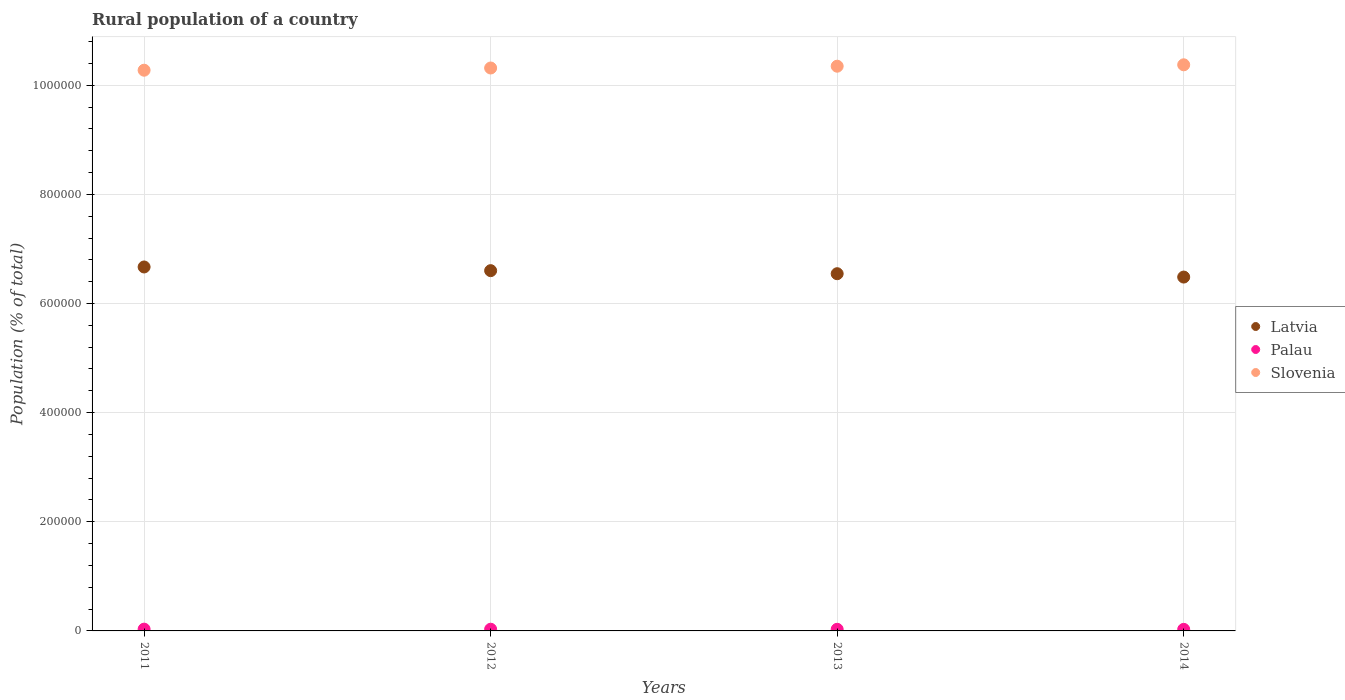How many different coloured dotlines are there?
Keep it short and to the point. 3. What is the rural population in Slovenia in 2013?
Offer a very short reply. 1.03e+06. Across all years, what is the maximum rural population in Latvia?
Provide a succinct answer. 6.67e+05. Across all years, what is the minimum rural population in Latvia?
Your response must be concise. 6.48e+05. In which year was the rural population in Slovenia maximum?
Your answer should be compact. 2014. In which year was the rural population in Palau minimum?
Your answer should be compact. 2014. What is the total rural population in Slovenia in the graph?
Keep it short and to the point. 4.13e+06. What is the difference between the rural population in Slovenia in 2011 and that in 2014?
Give a very brief answer. -9910. What is the difference between the rural population in Latvia in 2013 and the rural population in Palau in 2014?
Make the answer very short. 6.52e+05. What is the average rural population in Palau per year?
Ensure brevity in your answer.  3047. In the year 2011, what is the difference between the rural population in Slovenia and rural population in Palau?
Ensure brevity in your answer.  1.02e+06. In how many years, is the rural population in Slovenia greater than 960000 %?
Provide a succinct answer. 4. What is the ratio of the rural population in Palau in 2013 to that in 2014?
Provide a short and direct response. 1.04. Is the difference between the rural population in Slovenia in 2013 and 2014 greater than the difference between the rural population in Palau in 2013 and 2014?
Your answer should be very brief. No. What is the difference between the highest and the second highest rural population in Slovenia?
Your answer should be very brief. 2561. What is the difference between the highest and the lowest rural population in Palau?
Your response must be concise. 391. Does the rural population in Latvia monotonically increase over the years?
Offer a terse response. No. Is the rural population in Latvia strictly greater than the rural population in Slovenia over the years?
Provide a short and direct response. No. How many dotlines are there?
Ensure brevity in your answer.  3. What is the difference between two consecutive major ticks on the Y-axis?
Provide a succinct answer. 2.00e+05. Are the values on the major ticks of Y-axis written in scientific E-notation?
Your answer should be very brief. No. Does the graph contain grids?
Provide a succinct answer. Yes. How many legend labels are there?
Provide a succinct answer. 3. What is the title of the graph?
Provide a short and direct response. Rural population of a country. What is the label or title of the X-axis?
Give a very brief answer. Years. What is the label or title of the Y-axis?
Provide a short and direct response. Population (% of total). What is the Population (% of total) in Latvia in 2011?
Give a very brief answer. 6.67e+05. What is the Population (% of total) in Palau in 2011?
Offer a very short reply. 3249. What is the Population (% of total) in Slovenia in 2011?
Make the answer very short. 1.03e+06. What is the Population (% of total) in Latvia in 2012?
Keep it short and to the point. 6.60e+05. What is the Population (% of total) in Palau in 2012?
Make the answer very short. 3105. What is the Population (% of total) of Slovenia in 2012?
Provide a short and direct response. 1.03e+06. What is the Population (% of total) of Latvia in 2013?
Provide a short and direct response. 6.55e+05. What is the Population (% of total) of Palau in 2013?
Give a very brief answer. 2976. What is the Population (% of total) of Slovenia in 2013?
Give a very brief answer. 1.03e+06. What is the Population (% of total) of Latvia in 2014?
Your answer should be very brief. 6.48e+05. What is the Population (% of total) in Palau in 2014?
Provide a succinct answer. 2858. What is the Population (% of total) in Slovenia in 2014?
Make the answer very short. 1.04e+06. Across all years, what is the maximum Population (% of total) in Latvia?
Offer a terse response. 6.67e+05. Across all years, what is the maximum Population (% of total) in Palau?
Offer a terse response. 3249. Across all years, what is the maximum Population (% of total) of Slovenia?
Ensure brevity in your answer.  1.04e+06. Across all years, what is the minimum Population (% of total) of Latvia?
Provide a succinct answer. 6.48e+05. Across all years, what is the minimum Population (% of total) in Palau?
Offer a very short reply. 2858. Across all years, what is the minimum Population (% of total) in Slovenia?
Provide a succinct answer. 1.03e+06. What is the total Population (% of total) of Latvia in the graph?
Ensure brevity in your answer.  2.63e+06. What is the total Population (% of total) of Palau in the graph?
Your answer should be very brief. 1.22e+04. What is the total Population (% of total) of Slovenia in the graph?
Your answer should be very brief. 4.13e+06. What is the difference between the Population (% of total) in Latvia in 2011 and that in 2012?
Offer a terse response. 6757. What is the difference between the Population (% of total) of Palau in 2011 and that in 2012?
Your answer should be compact. 144. What is the difference between the Population (% of total) in Slovenia in 2011 and that in 2012?
Provide a succinct answer. -4053. What is the difference between the Population (% of total) of Latvia in 2011 and that in 2013?
Your response must be concise. 1.23e+04. What is the difference between the Population (% of total) in Palau in 2011 and that in 2013?
Give a very brief answer. 273. What is the difference between the Population (% of total) of Slovenia in 2011 and that in 2013?
Your answer should be compact. -7349. What is the difference between the Population (% of total) of Latvia in 2011 and that in 2014?
Provide a succinct answer. 1.85e+04. What is the difference between the Population (% of total) in Palau in 2011 and that in 2014?
Your answer should be compact. 391. What is the difference between the Population (% of total) of Slovenia in 2011 and that in 2014?
Your answer should be compact. -9910. What is the difference between the Population (% of total) of Latvia in 2012 and that in 2013?
Your response must be concise. 5584. What is the difference between the Population (% of total) in Palau in 2012 and that in 2013?
Your answer should be compact. 129. What is the difference between the Population (% of total) of Slovenia in 2012 and that in 2013?
Your answer should be compact. -3296. What is the difference between the Population (% of total) in Latvia in 2012 and that in 2014?
Provide a succinct answer. 1.17e+04. What is the difference between the Population (% of total) in Palau in 2012 and that in 2014?
Ensure brevity in your answer.  247. What is the difference between the Population (% of total) of Slovenia in 2012 and that in 2014?
Your answer should be compact. -5857. What is the difference between the Population (% of total) in Latvia in 2013 and that in 2014?
Provide a short and direct response. 6157. What is the difference between the Population (% of total) in Palau in 2013 and that in 2014?
Make the answer very short. 118. What is the difference between the Population (% of total) in Slovenia in 2013 and that in 2014?
Give a very brief answer. -2561. What is the difference between the Population (% of total) of Latvia in 2011 and the Population (% of total) of Palau in 2012?
Provide a short and direct response. 6.64e+05. What is the difference between the Population (% of total) in Latvia in 2011 and the Population (% of total) in Slovenia in 2012?
Give a very brief answer. -3.65e+05. What is the difference between the Population (% of total) in Palau in 2011 and the Population (% of total) in Slovenia in 2012?
Your response must be concise. -1.03e+06. What is the difference between the Population (% of total) in Latvia in 2011 and the Population (% of total) in Palau in 2013?
Ensure brevity in your answer.  6.64e+05. What is the difference between the Population (% of total) in Latvia in 2011 and the Population (% of total) in Slovenia in 2013?
Give a very brief answer. -3.68e+05. What is the difference between the Population (% of total) of Palau in 2011 and the Population (% of total) of Slovenia in 2013?
Offer a terse response. -1.03e+06. What is the difference between the Population (% of total) of Latvia in 2011 and the Population (% of total) of Palau in 2014?
Offer a very short reply. 6.64e+05. What is the difference between the Population (% of total) of Latvia in 2011 and the Population (% of total) of Slovenia in 2014?
Ensure brevity in your answer.  -3.70e+05. What is the difference between the Population (% of total) in Palau in 2011 and the Population (% of total) in Slovenia in 2014?
Your response must be concise. -1.03e+06. What is the difference between the Population (% of total) in Latvia in 2012 and the Population (% of total) in Palau in 2013?
Your answer should be compact. 6.57e+05. What is the difference between the Population (% of total) of Latvia in 2012 and the Population (% of total) of Slovenia in 2013?
Provide a succinct answer. -3.75e+05. What is the difference between the Population (% of total) in Palau in 2012 and the Population (% of total) in Slovenia in 2013?
Your response must be concise. -1.03e+06. What is the difference between the Population (% of total) in Latvia in 2012 and the Population (% of total) in Palau in 2014?
Give a very brief answer. 6.57e+05. What is the difference between the Population (% of total) in Latvia in 2012 and the Population (% of total) in Slovenia in 2014?
Your answer should be very brief. -3.77e+05. What is the difference between the Population (% of total) in Palau in 2012 and the Population (% of total) in Slovenia in 2014?
Provide a succinct answer. -1.03e+06. What is the difference between the Population (% of total) of Latvia in 2013 and the Population (% of total) of Palau in 2014?
Provide a succinct answer. 6.52e+05. What is the difference between the Population (% of total) in Latvia in 2013 and the Population (% of total) in Slovenia in 2014?
Your answer should be compact. -3.83e+05. What is the difference between the Population (% of total) in Palau in 2013 and the Population (% of total) in Slovenia in 2014?
Give a very brief answer. -1.03e+06. What is the average Population (% of total) in Latvia per year?
Make the answer very short. 6.58e+05. What is the average Population (% of total) of Palau per year?
Ensure brevity in your answer.  3047. What is the average Population (% of total) in Slovenia per year?
Give a very brief answer. 1.03e+06. In the year 2011, what is the difference between the Population (% of total) in Latvia and Population (% of total) in Palau?
Your answer should be compact. 6.64e+05. In the year 2011, what is the difference between the Population (% of total) in Latvia and Population (% of total) in Slovenia?
Keep it short and to the point. -3.61e+05. In the year 2011, what is the difference between the Population (% of total) of Palau and Population (% of total) of Slovenia?
Make the answer very short. -1.02e+06. In the year 2012, what is the difference between the Population (% of total) of Latvia and Population (% of total) of Palau?
Your response must be concise. 6.57e+05. In the year 2012, what is the difference between the Population (% of total) of Latvia and Population (% of total) of Slovenia?
Give a very brief answer. -3.71e+05. In the year 2012, what is the difference between the Population (% of total) of Palau and Population (% of total) of Slovenia?
Offer a very short reply. -1.03e+06. In the year 2013, what is the difference between the Population (% of total) in Latvia and Population (% of total) in Palau?
Provide a succinct answer. 6.52e+05. In the year 2013, what is the difference between the Population (% of total) of Latvia and Population (% of total) of Slovenia?
Keep it short and to the point. -3.80e+05. In the year 2013, what is the difference between the Population (% of total) in Palau and Population (% of total) in Slovenia?
Give a very brief answer. -1.03e+06. In the year 2014, what is the difference between the Population (% of total) of Latvia and Population (% of total) of Palau?
Make the answer very short. 6.46e+05. In the year 2014, what is the difference between the Population (% of total) of Latvia and Population (% of total) of Slovenia?
Ensure brevity in your answer.  -3.89e+05. In the year 2014, what is the difference between the Population (% of total) in Palau and Population (% of total) in Slovenia?
Your answer should be compact. -1.03e+06. What is the ratio of the Population (% of total) in Latvia in 2011 to that in 2012?
Ensure brevity in your answer.  1.01. What is the ratio of the Population (% of total) of Palau in 2011 to that in 2012?
Ensure brevity in your answer.  1.05. What is the ratio of the Population (% of total) of Slovenia in 2011 to that in 2012?
Provide a short and direct response. 1. What is the ratio of the Population (% of total) of Latvia in 2011 to that in 2013?
Offer a terse response. 1.02. What is the ratio of the Population (% of total) of Palau in 2011 to that in 2013?
Provide a succinct answer. 1.09. What is the ratio of the Population (% of total) in Slovenia in 2011 to that in 2013?
Keep it short and to the point. 0.99. What is the ratio of the Population (% of total) of Latvia in 2011 to that in 2014?
Give a very brief answer. 1.03. What is the ratio of the Population (% of total) in Palau in 2011 to that in 2014?
Give a very brief answer. 1.14. What is the ratio of the Population (% of total) in Latvia in 2012 to that in 2013?
Your answer should be very brief. 1.01. What is the ratio of the Population (% of total) in Palau in 2012 to that in 2013?
Provide a short and direct response. 1.04. What is the ratio of the Population (% of total) of Latvia in 2012 to that in 2014?
Provide a succinct answer. 1.02. What is the ratio of the Population (% of total) of Palau in 2012 to that in 2014?
Give a very brief answer. 1.09. What is the ratio of the Population (% of total) in Latvia in 2013 to that in 2014?
Give a very brief answer. 1.01. What is the ratio of the Population (% of total) of Palau in 2013 to that in 2014?
Your answer should be compact. 1.04. What is the difference between the highest and the second highest Population (% of total) of Latvia?
Your answer should be compact. 6757. What is the difference between the highest and the second highest Population (% of total) in Palau?
Offer a very short reply. 144. What is the difference between the highest and the second highest Population (% of total) in Slovenia?
Your answer should be compact. 2561. What is the difference between the highest and the lowest Population (% of total) in Latvia?
Provide a succinct answer. 1.85e+04. What is the difference between the highest and the lowest Population (% of total) of Palau?
Your answer should be very brief. 391. What is the difference between the highest and the lowest Population (% of total) in Slovenia?
Provide a short and direct response. 9910. 